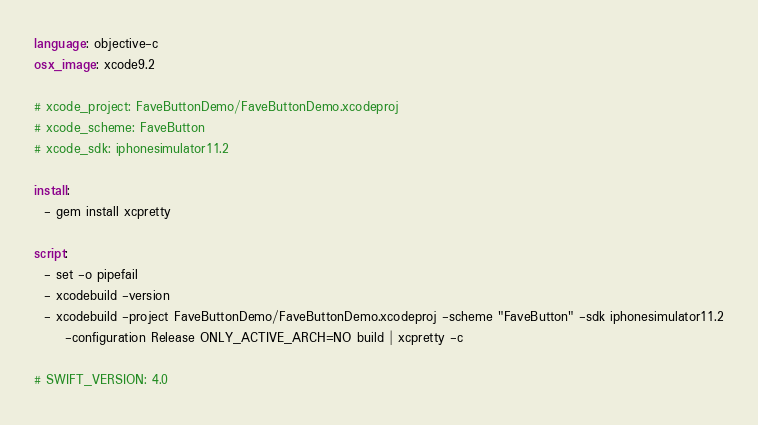Convert code to text. <code><loc_0><loc_0><loc_500><loc_500><_YAML_>language: objective-c
osx_image: xcode9.2

# xcode_project: FaveButtonDemo/FaveButtonDemo.xcodeproj
# xcode_scheme: FaveButton
# xcode_sdk: iphonesimulator11.2

install:
  - gem install xcpretty

script:
  - set -o pipefail
  - xcodebuild -version
  - xcodebuild -project FaveButtonDemo/FaveButtonDemo.xcodeproj -scheme "FaveButton" -sdk iphonesimulator11.2
      -configuration Release ONLY_ACTIVE_ARCH=NO build | xcpretty -c  

# SWIFT_VERSION: 4.0
</code> 